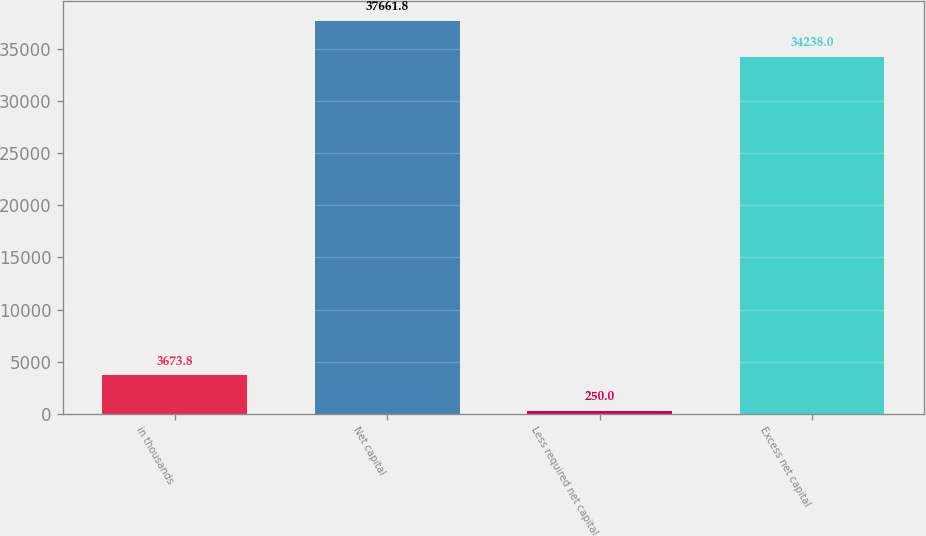Convert chart to OTSL. <chart><loc_0><loc_0><loc_500><loc_500><bar_chart><fcel>in thousands<fcel>Net capital<fcel>Less required net capital<fcel>Excess net capital<nl><fcel>3673.8<fcel>37661.8<fcel>250<fcel>34238<nl></chart> 